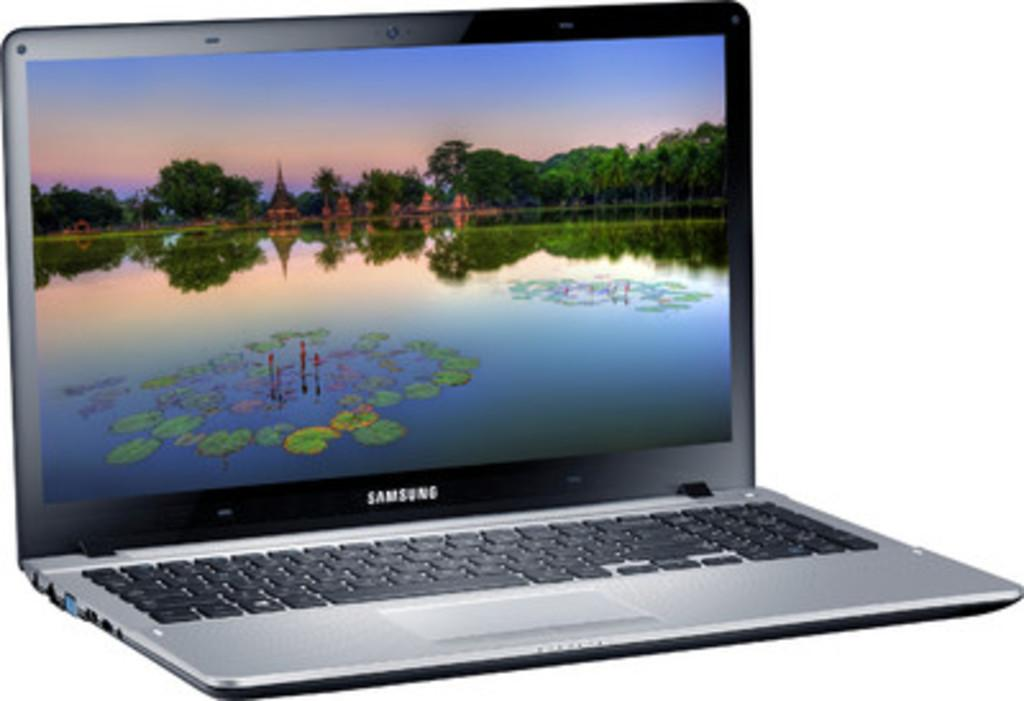<image>
Relay a brief, clear account of the picture shown. A Samsung laptop is open with a screensaver showing a pond. 